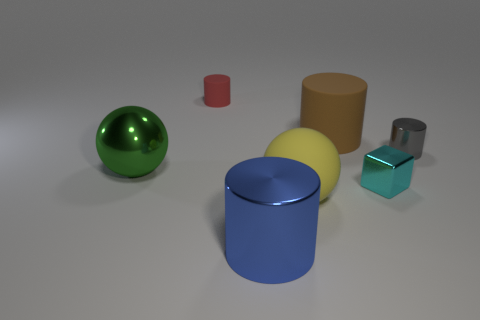Subtract all large matte cylinders. How many cylinders are left? 3 Add 2 cylinders. How many objects exist? 9 Subtract all blue cylinders. How many cylinders are left? 3 Subtract 1 cylinders. How many cylinders are left? 3 Subtract all spheres. How many objects are left? 5 Subtract all blue cylinders. Subtract all brown cubes. How many cylinders are left? 3 Add 2 blue shiny cylinders. How many blue shiny cylinders exist? 3 Subtract 0 gray cubes. How many objects are left? 7 Subtract all small cyan things. Subtract all tiny blocks. How many objects are left? 5 Add 4 large blue cylinders. How many large blue cylinders are left? 5 